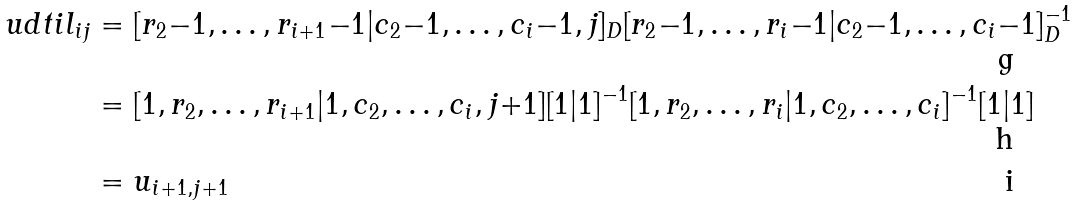Convert formula to latex. <formula><loc_0><loc_0><loc_500><loc_500>\ u d t i l _ { i j } & = [ r _ { 2 } { - } 1 , \dots , r _ { i + 1 } { - } 1 | c _ { 2 } { - } 1 , \dots , c _ { i } { - } 1 , j ] _ { D } [ r _ { 2 } { - } 1 , \dots , r _ { i } { - } 1 | c _ { 2 } { - } 1 , \dots , c _ { i } { - } 1 ] _ { D } ^ { - 1 } \\ & = [ 1 , r _ { 2 } , \dots , r _ { i + 1 } | 1 , c _ { 2 } , \dots , c _ { i } , j { + } 1 ] [ 1 | 1 ] ^ { - 1 } [ 1 , r _ { 2 } , \dots , r _ { i } | 1 , c _ { 2 } , \dots , c _ { i } ] ^ { - 1 } [ 1 | 1 ] \\ & = u _ { i + 1 , j + 1 }</formula> 